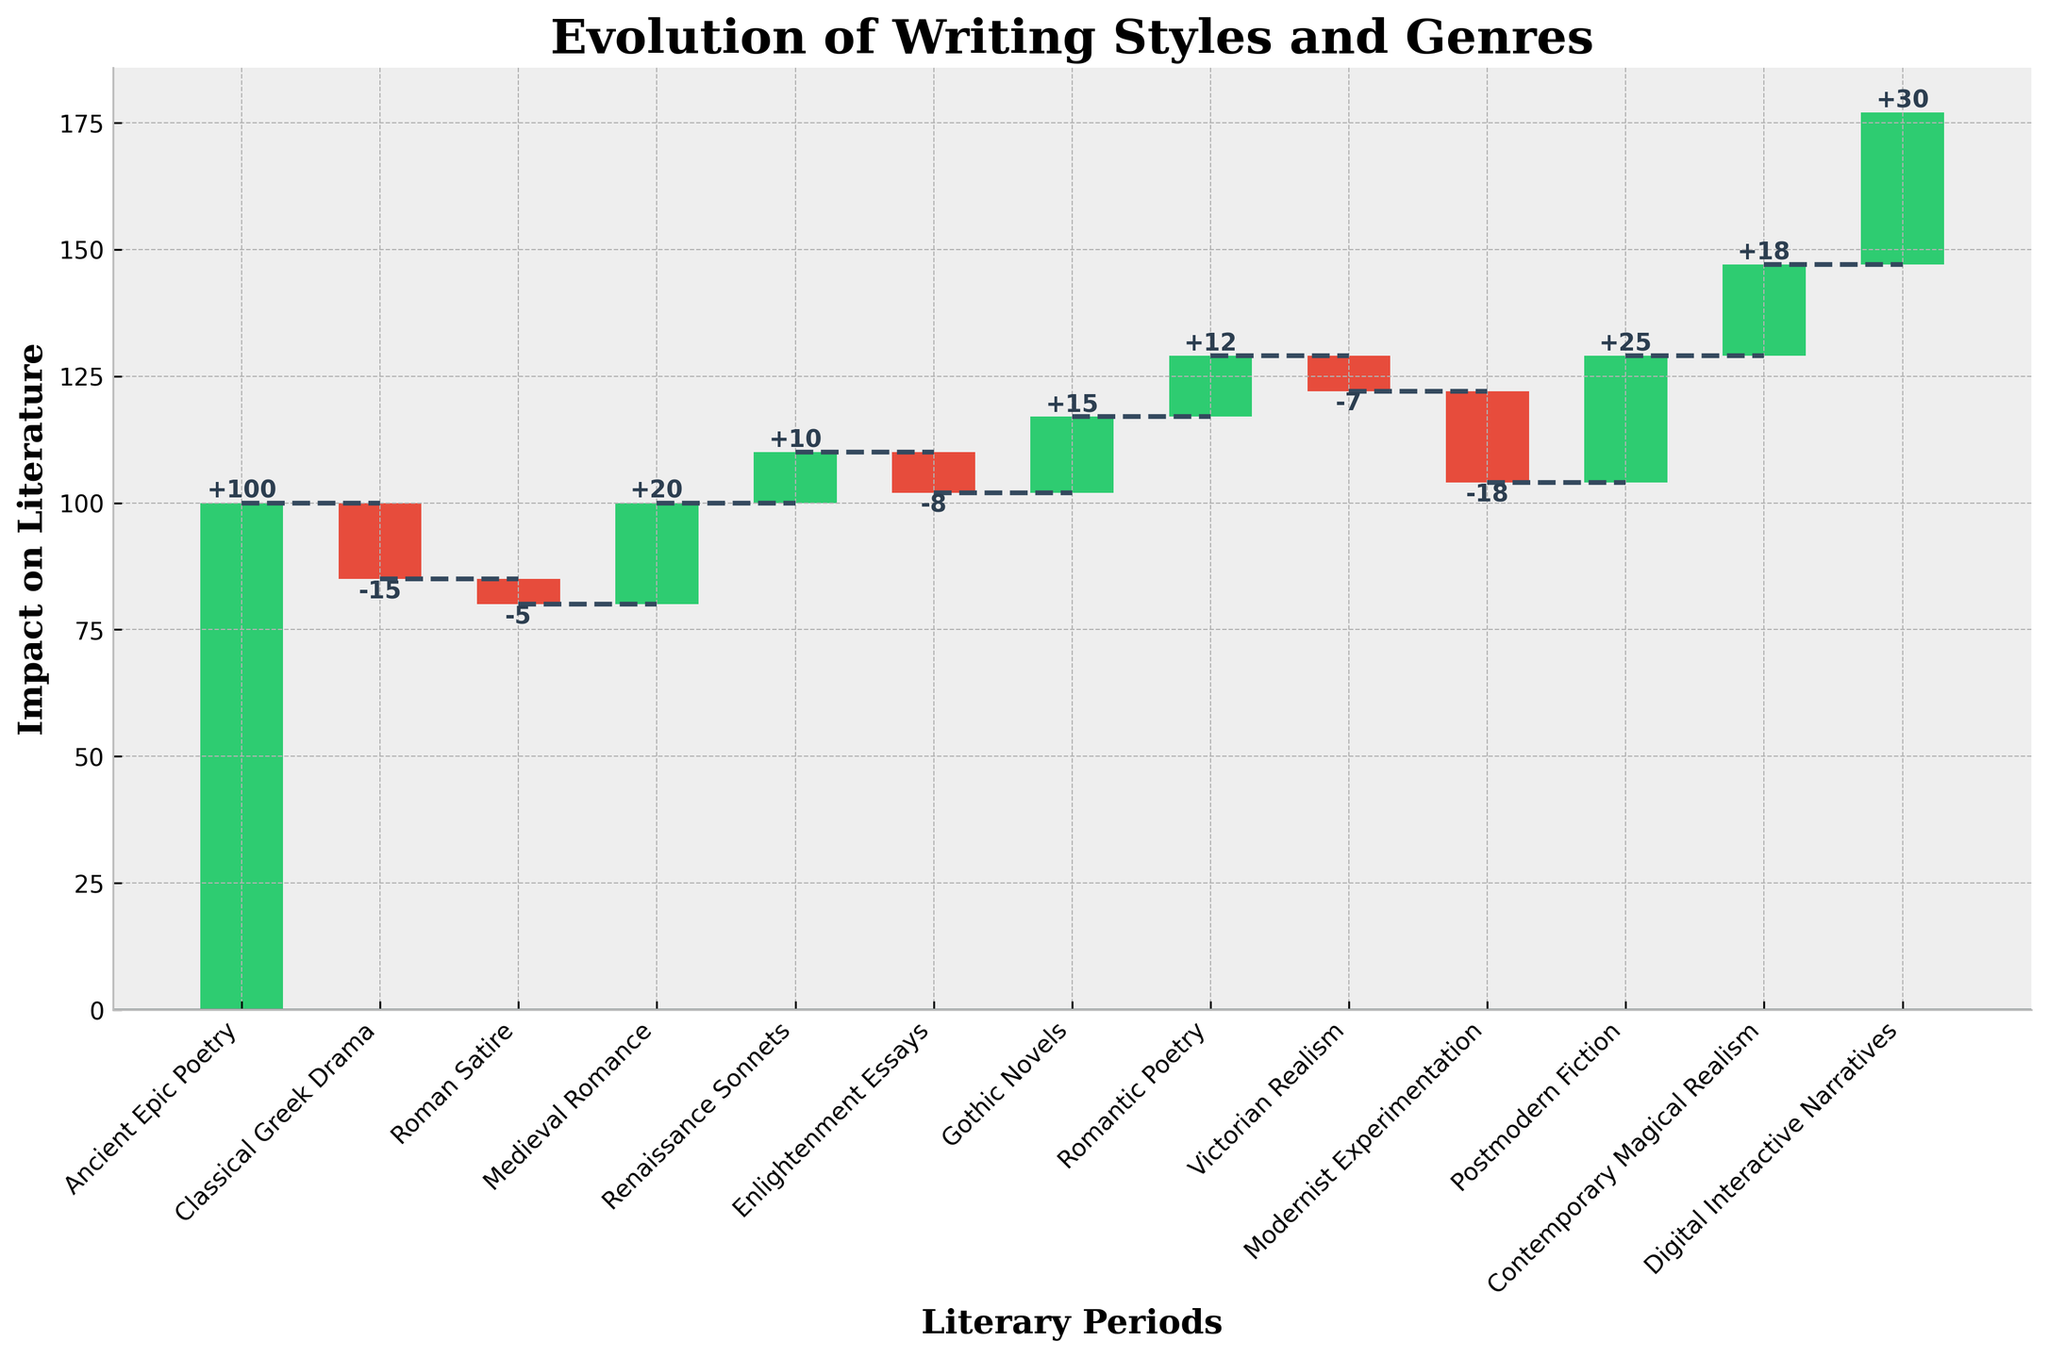What's the title of the figure? The title is usually displayed at the top of the plot. In this case, it's written in bold and serif font.
Answer: Evolution of Writing Styles and Genres How many literary periods are represented? To find the number of literary periods, count the number of categories on the x-axis of the plot. Do not include categories that were excluded for calculation purposes.
Answer: 12 Which literary period has the greatest positive impact on literature? Look for the category with the tallest green bar pointing upward, as green indicates a positive impact. This category will have the highest positive number.
Answer: Digital Interactive Narratives What is the total cumulative impact at the end of the last literary period? The cumulative impact at the end is represented by the y-value at the end of the last bar. Add up all values cumulatively until the last one.
Answer: 162 How does the impact of Classical Greek Drama compare to that of Roman Satire? Compare the height and orientation of the bars for Classical Greek Drama and Roman Satire. Both are red, indicating a negative impact, but differ in magnitude.
Answer: Classical Greek Drama has a greater negative impact than Roman Satire What is the total change in impact from Ancient Epic Poetry to Digital Interactive Narratives? Calculate the total change by summing all individual impacts from each category from Ancient Epic Poetry to Digital Interactive Narratives.
Answer: +77 Which literary period had the smallest negative impact, and what was its value? Look for the smallest red bar on the chart to find the literary period and its corresponding negative value.
Answer: Roman Satire, -5 What's the average impact of Enlightenment Essays, Gothic Novels, and Romantic Poetry? Add the impacts of Enlightenment Essays, Gothic Novels, and Romantic Poetry, then divide by the number of these periods.
Answer: ( -8 + 15 + 12 ) / 3 = 6.33 What is the overall impact of literature from Ancient Epic Poetry to Postmodern Fiction, and how does it compare to the final cumulative impact? Sum the impacts of all periods up to Postmodern Fiction, then compare this value to the total cumulative impact, which already includes the final contribution from Digital Interactive Narratives.
Answer: 129 compared to 162 How did Modernist Experimentation impact the overall trend of literary styles? Identify the value of Modernist Experimentation and note its color. This will indicate whether its impact was positive or negative, and then consider its position in the sequence to evaluate how it influenced the overall trend.
Answer: It had a negative impact of -18, contributing to a decline in the overall trend before later positive contributions 